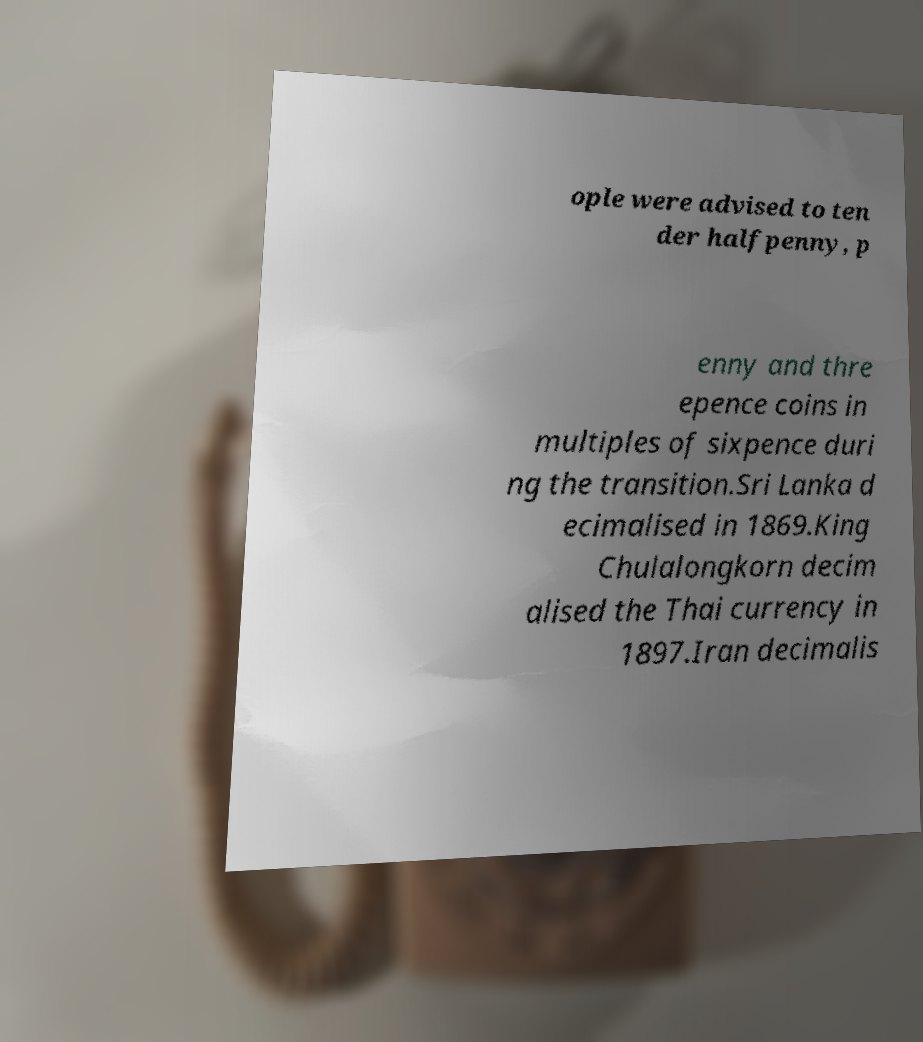Please identify and transcribe the text found in this image. ople were advised to ten der halfpenny, p enny and thre epence coins in multiples of sixpence duri ng the transition.Sri Lanka d ecimalised in 1869.King Chulalongkorn decim alised the Thai currency in 1897.Iran decimalis 